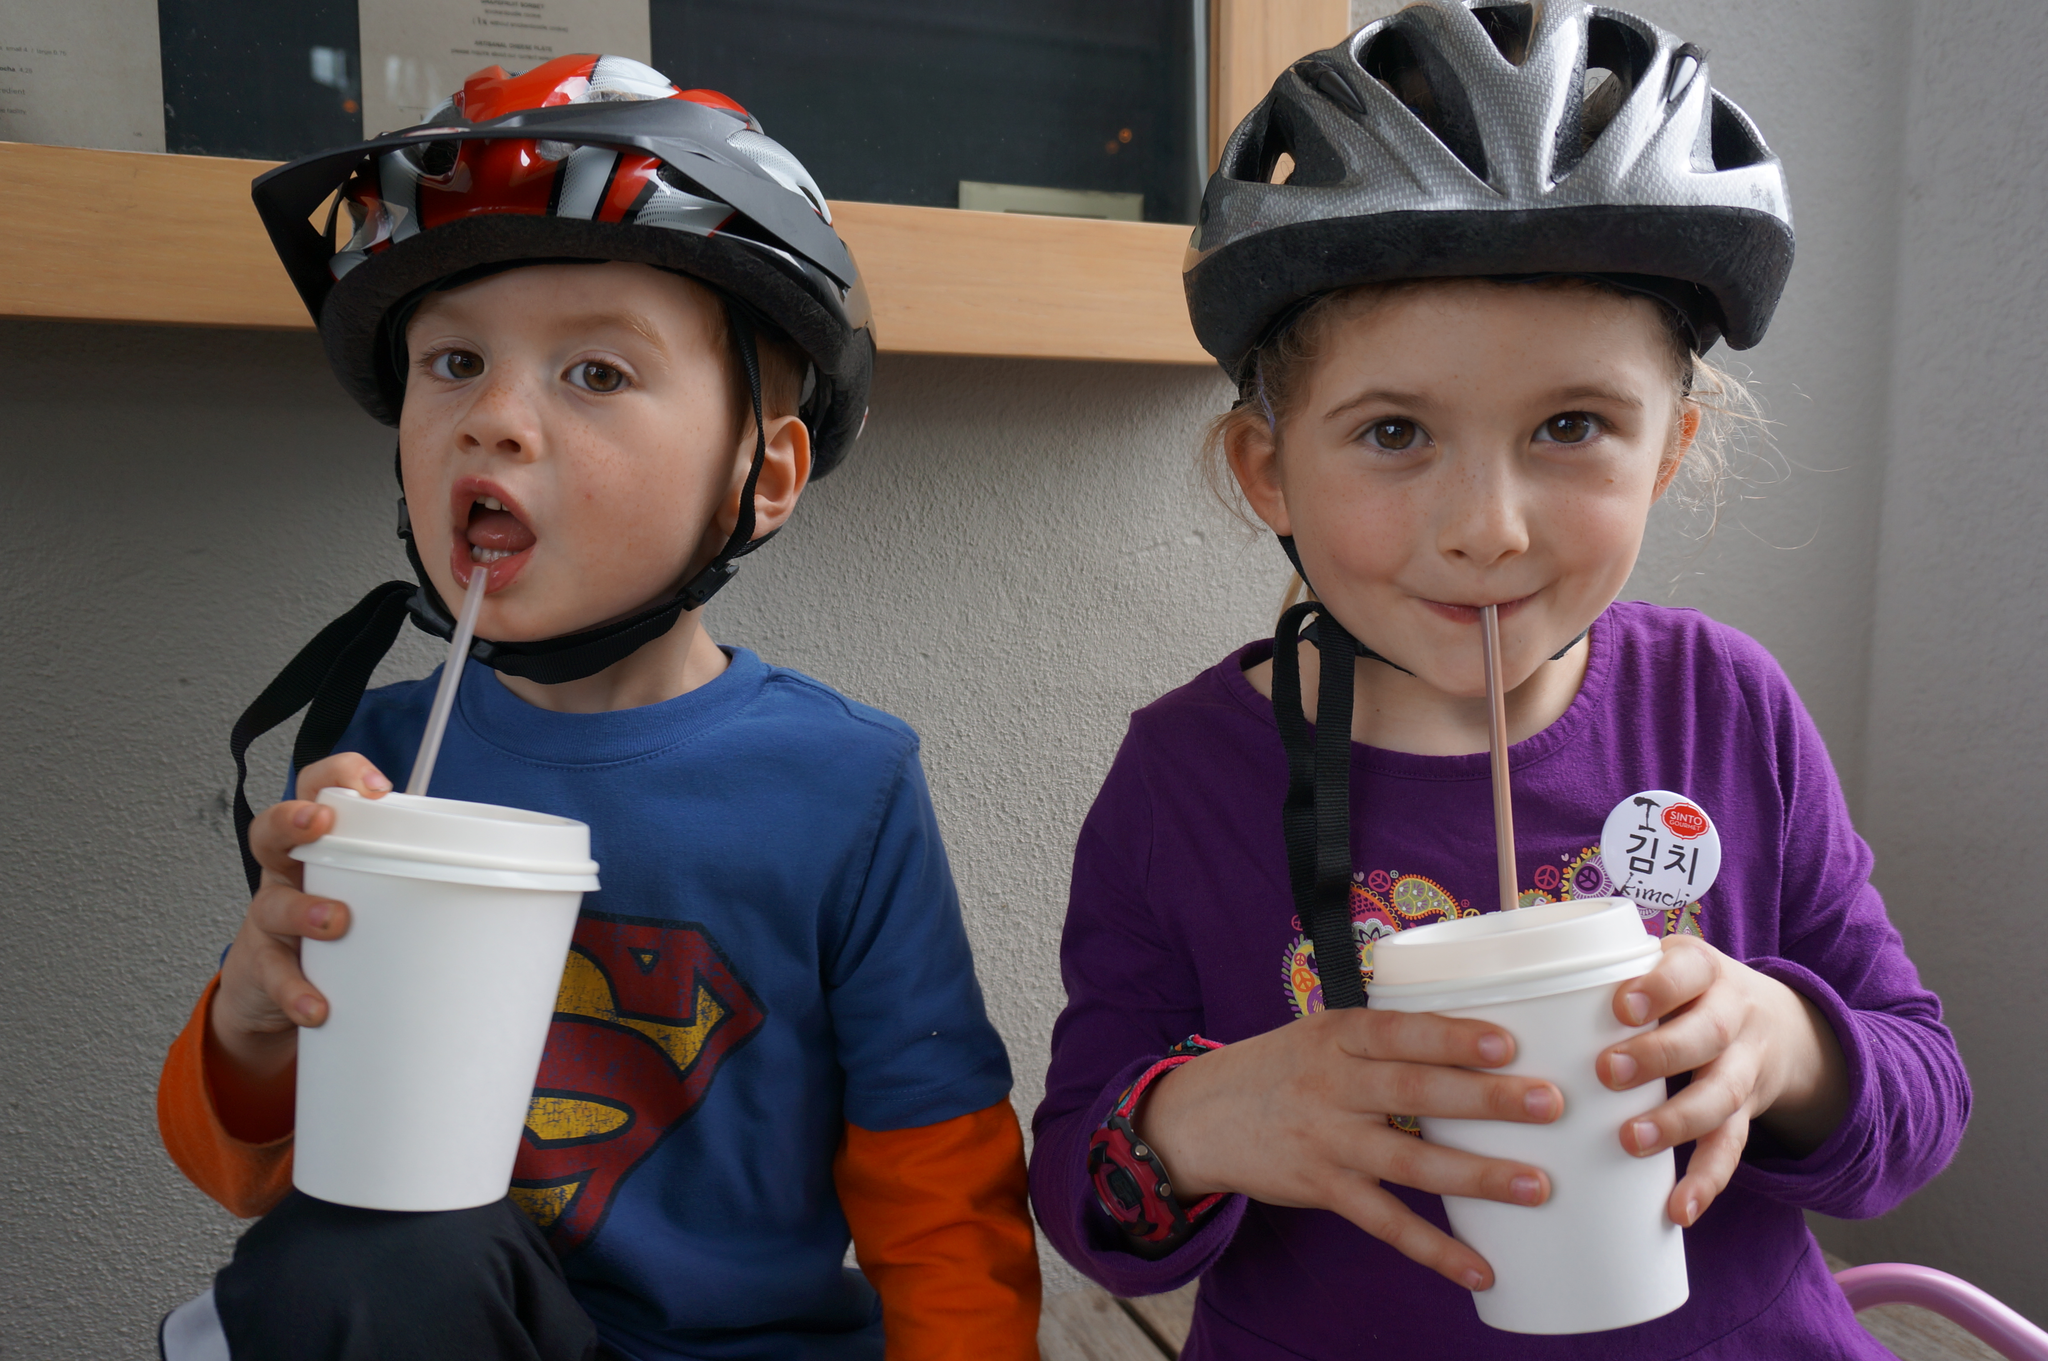Please provide a concise description of this image. In the image two kids are sitting and holding cups and smiling. Behind them there is a wall, on the wall there is a frame. 